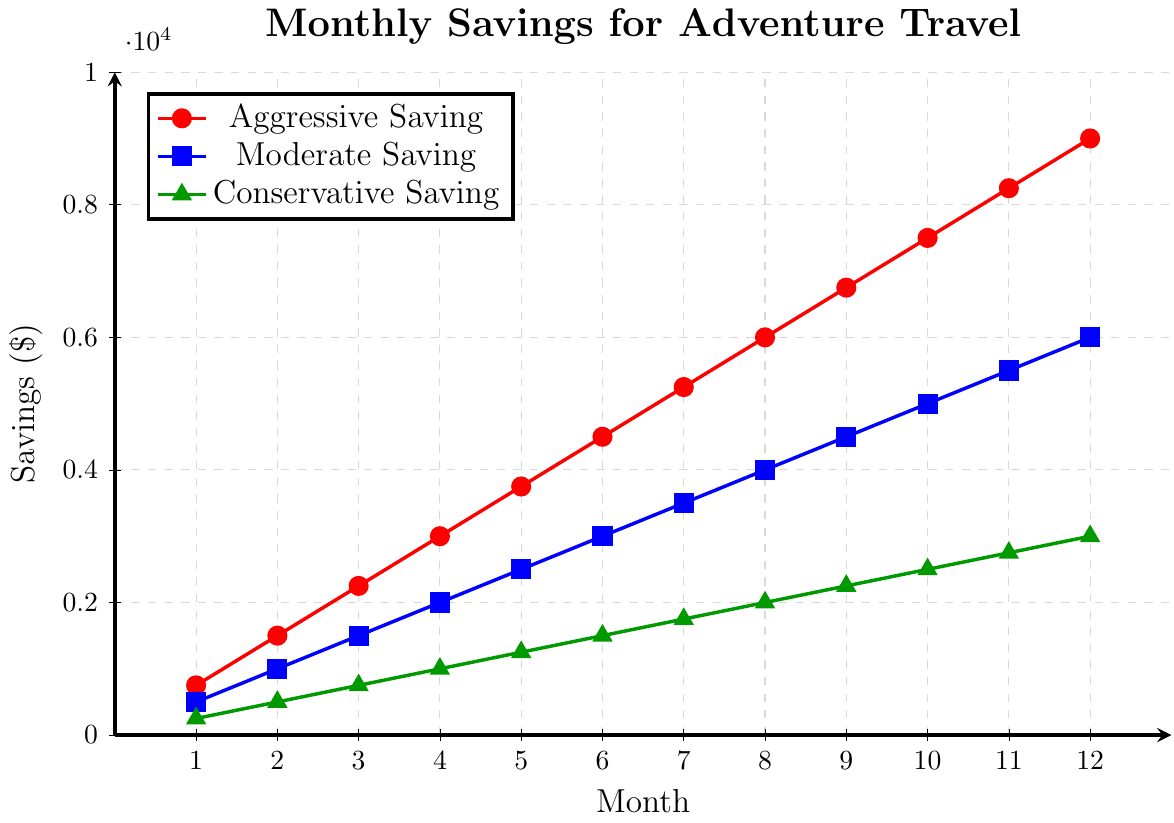Which saving strategy leads to the highest savings by the end of the year? According to the visual information, the Aggressive Saving strategy (red line) consistently shows the highest values throughout all the months. By the end of the year (Month 12), it reaches $9000.
Answer: Aggressive Saving By how much did the Moderate Saving increase from Month 4 to Month 8? In Month 4, the Moderate Saving value is $2000, and in Month 8, it is $4000. To find the increase, subtract the Month 4 value from the Month 8 value: $4000 - $2000 = $2000.
Answer: $2000 Which month(s) did all three saving strategies have the smallest increase in savings compared to the previous month? With a consistent monthly increase for each strategy, each month has the same incremental increase. For Aggressive Saving, Moderate Saving, and Conservative Saving, the increases are $750, $500, and $250 per month respectively throughout all months. Therefore, every month shows the same incremental increase.
Answer: All months Across all months, what is the total savings for the Conservative Saving strategy? Sum the savings for each month for Conservative Saving: $250 + $500 + $750 + $1000 + $1250 + $1500 + $1750 + $2000 + $2250 + $2500 + $2750 + $3000 = $18000.
Answer: $18000 In which month does the Aggressive Saving strategy first exceed $5000? Look at the point where the Aggressive Saving (red line) first exceeds $5000. It reaches $5250 in Month 7.
Answer: Month 7 Compare the savings between the Aggressive and Conservative strategies in Month 10. What is the difference? In Month 10, the Aggressive Saving value is $7500 and the Conservative Saving value is $2500. To find the difference, subtract the Conservative value from the Aggressive value: $7500 - $2500 = $5000.
Answer: $5000 What is the average monthly savings for each strategy over the 12 months? Sum the savings for each month for each strategy and then divide by 12.
- For Aggressive Saving: $750 + $1500 + $2250 + $3000 + $3750 + $4500 + $5250 + $6000 + $6750 + $7500 + $8250 + $9000 = $99000, $99000 / 12 = $8250.
- For Moderate Saving: $500 + $1000 + $1500 + $2000 + $2500 + $3000 + $3500 + $4000 + $4500 + $5000 + $5500 + $6000 = $72000, $72000 / 12 = $6000.
- For Conservative Saving: $250 + $500 + $750 + $1000 + $1250 + $1500 + $1750 + $2000 + $2250 + $2500 + $2750 + $3000 = $36000, $36000 / 12 = $3000.
Answer: $8250 for Aggressive, $6000 for Moderate, $3000 for Conservative 